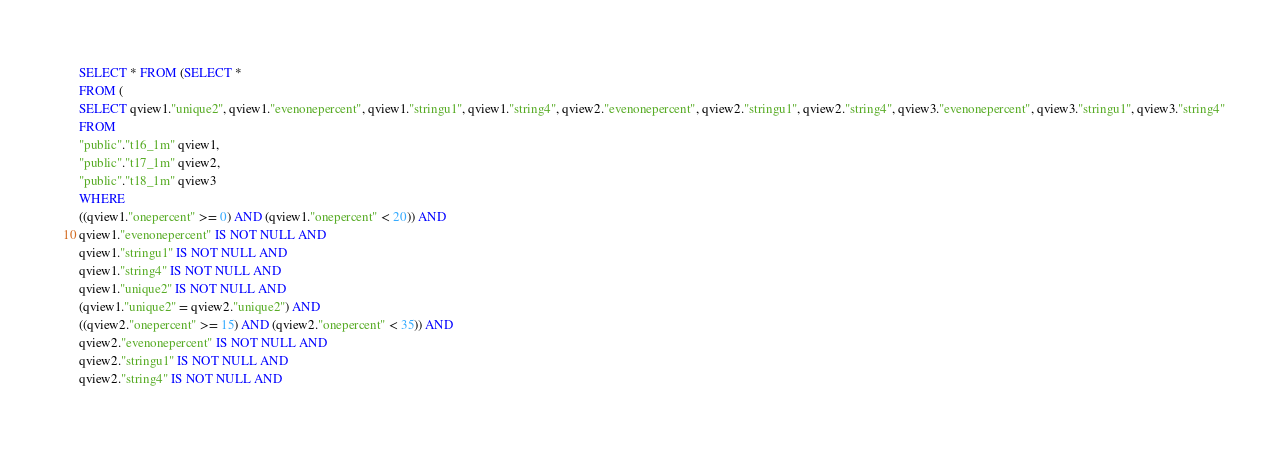Convert code to text. <code><loc_0><loc_0><loc_500><loc_500><_SQL_>SELECT * FROM (SELECT *
FROM (
SELECT qview1."unique2", qview1."evenonepercent", qview1."stringu1", qview1."string4", qview2."evenonepercent", qview2."stringu1", qview2."string4", qview3."evenonepercent", qview3."stringu1", qview3."string4"
FROM
"public"."t16_1m" qview1,
"public"."t17_1m" qview2,
"public"."t18_1m" qview3
WHERE
((qview1."onepercent" >= 0) AND (qview1."onepercent" < 20)) AND
qview1."evenonepercent" IS NOT NULL AND
qview1."stringu1" IS NOT NULL AND
qview1."string4" IS NOT NULL AND
qview1."unique2" IS NOT NULL AND
(qview1."unique2" = qview2."unique2") AND
((qview2."onepercent" >= 15) AND (qview2."onepercent" < 35)) AND
qview2."evenonepercent" IS NOT NULL AND
qview2."stringu1" IS NOT NULL AND
qview2."string4" IS NOT NULL AND</code> 